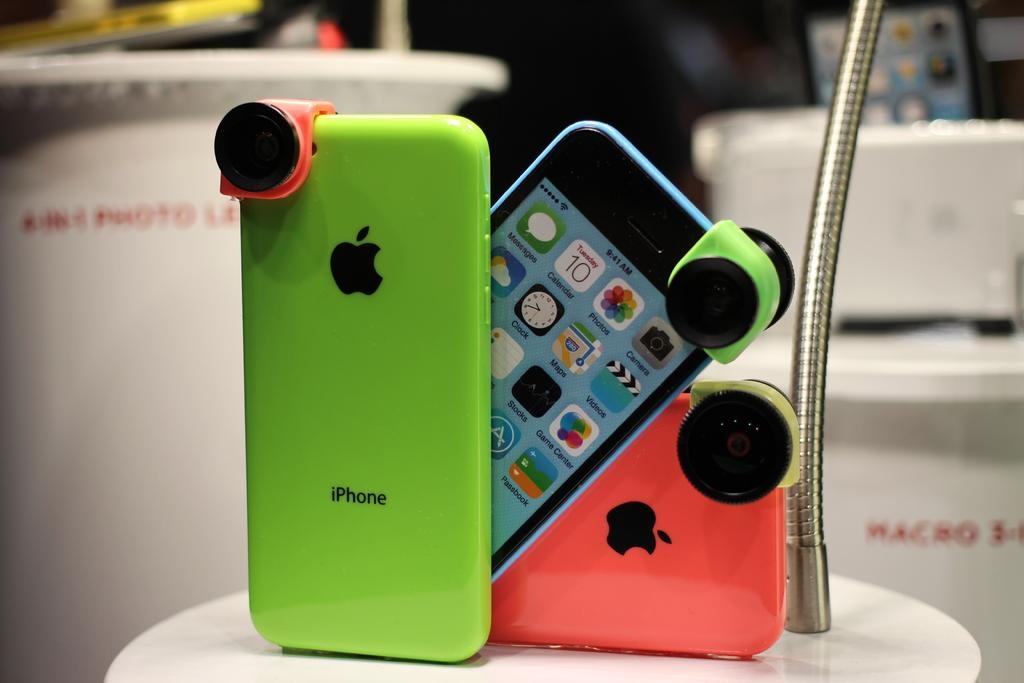<image>
Describe the image concisely. 3 different colored I phones in green, blue and pink. 